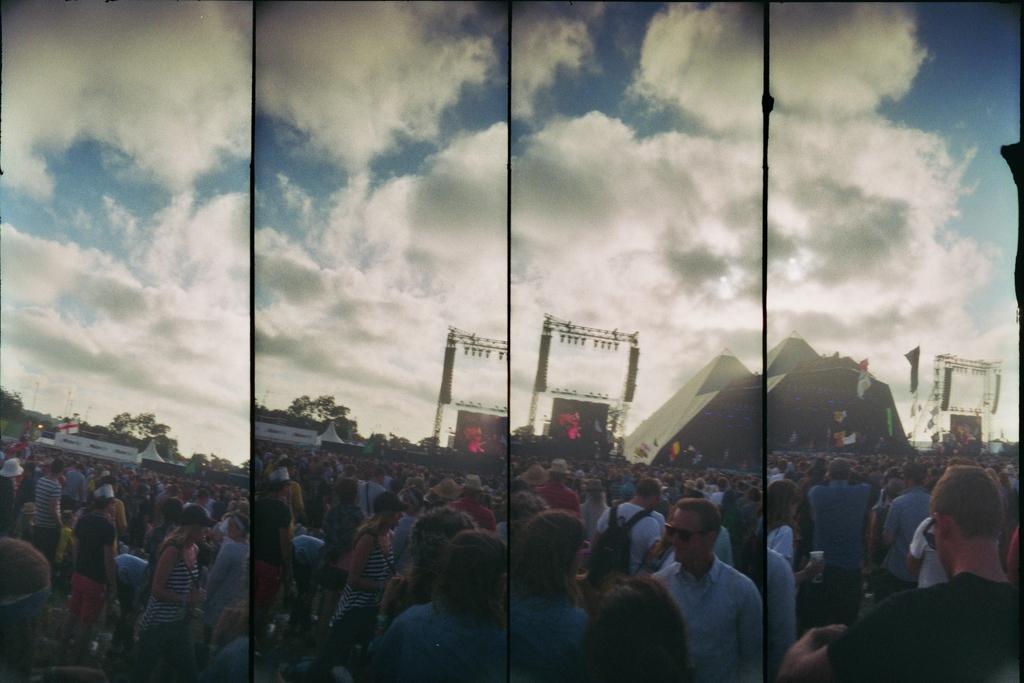In one or two sentences, can you explain what this image depicts? In this image we can see collage pictures of persons and sky. 